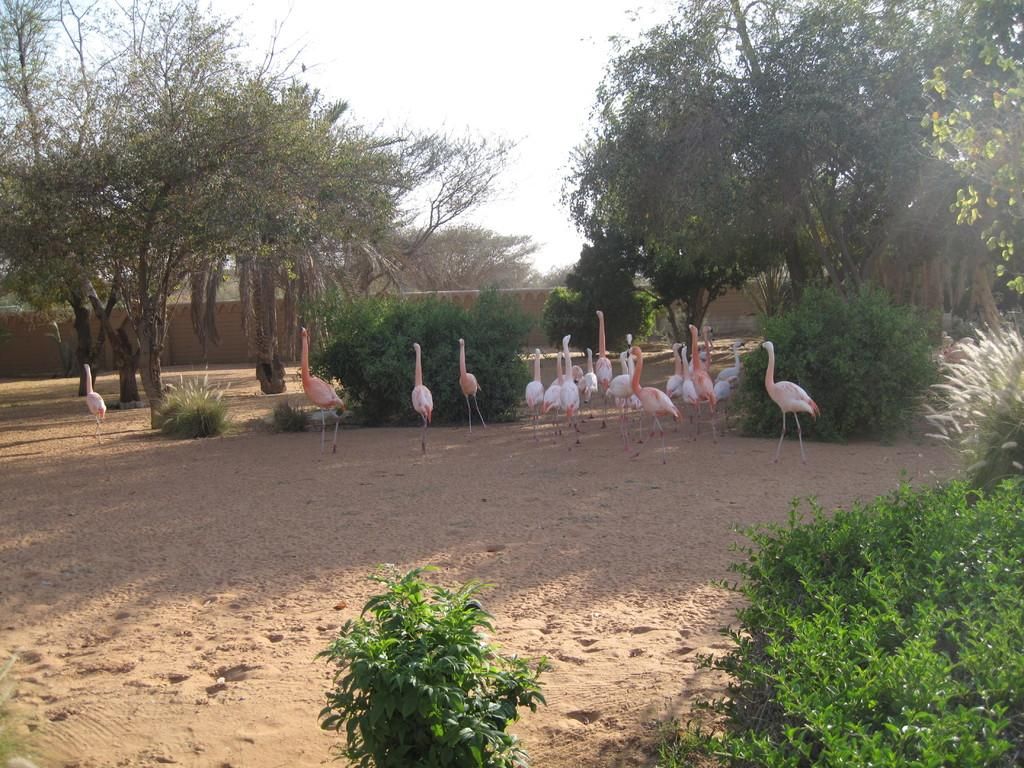What is located at the bottom of the image? There are plants at the bottom of the image. What can be seen in the middle of the image? There are flocks of birds and trees in the middle of the image. What type of barrier is present in the middle of the image? There is a fence in the middle of the image. What is visible at the top of the image? The sky is visible at the top of the image. When was the image taken? The image was taken during the day. Can you tell me how many doctors are present in the image? There are no doctors present in the image. What type of fruit is being held by the men in the image? There are no men or fruit present in the image. 